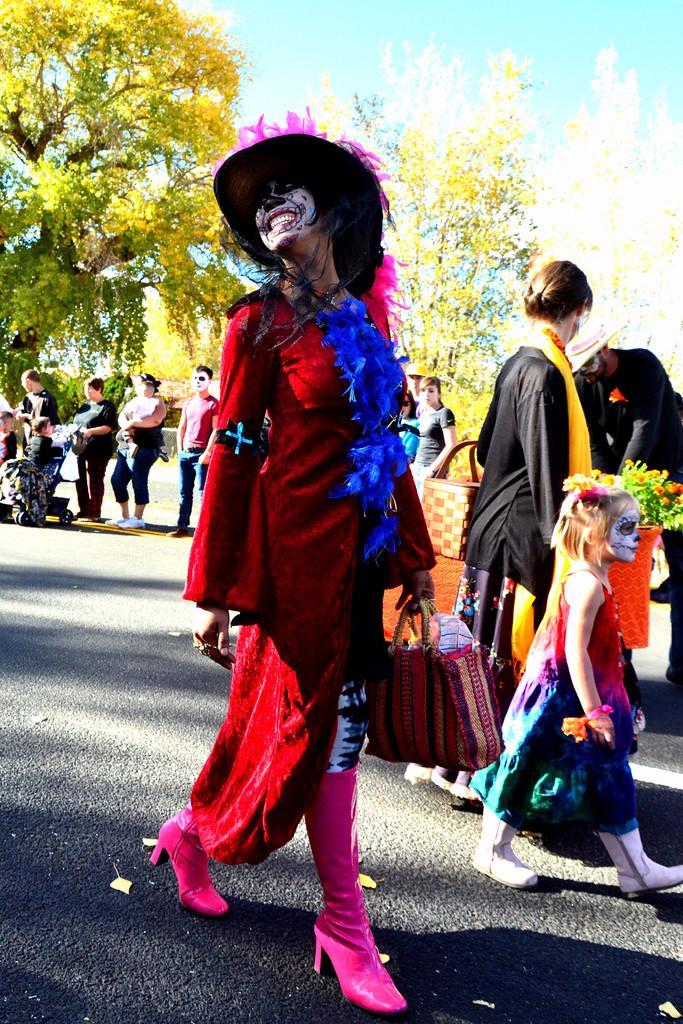Can you describe this image briefly? In this image there is a woman walking with a smile on her face, the woman is holding a bag and wearing a hat, behind the women there are few other people, in the background of the image there are trees. 